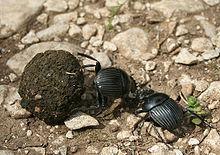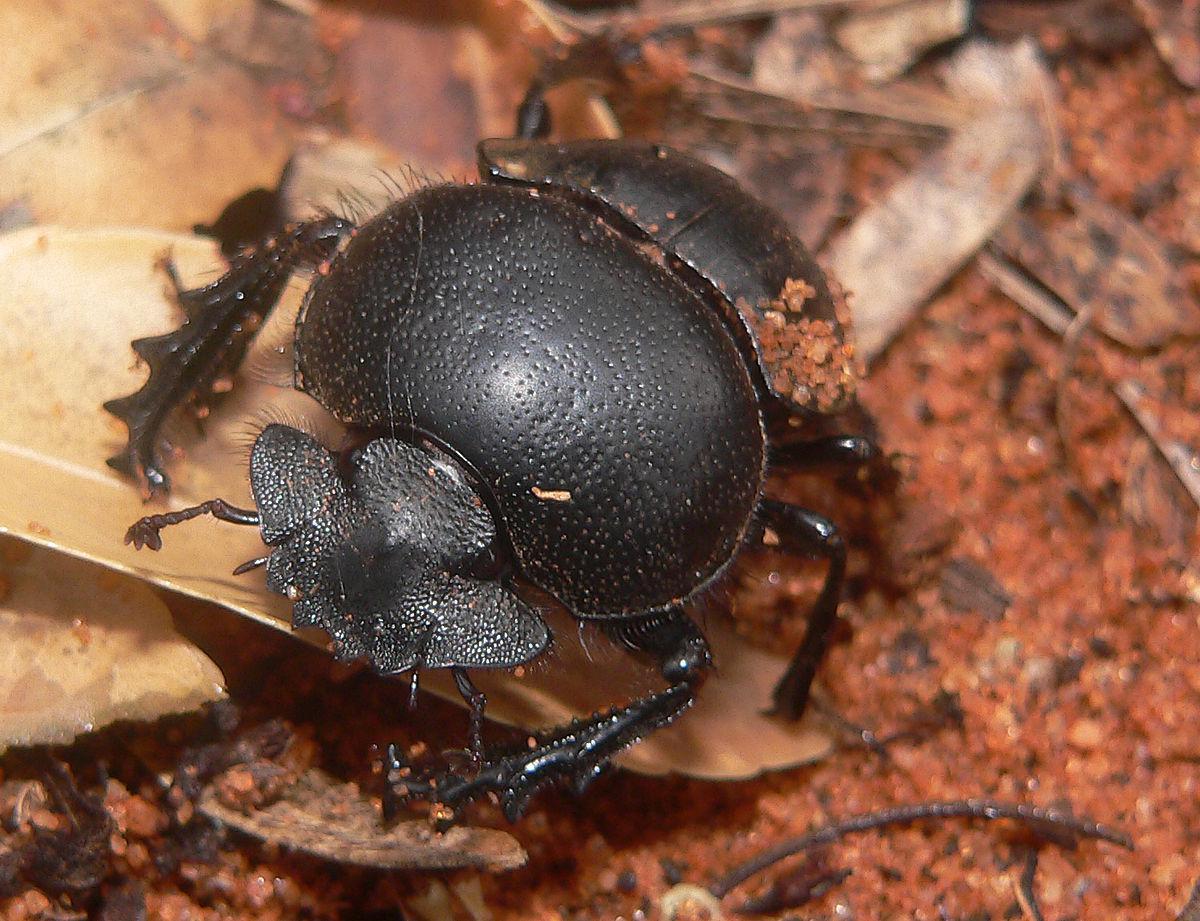The first image is the image on the left, the second image is the image on the right. Given the left and right images, does the statement "An image shows exactly two black beetles by one dung ball." hold true? Answer yes or no. Yes. 